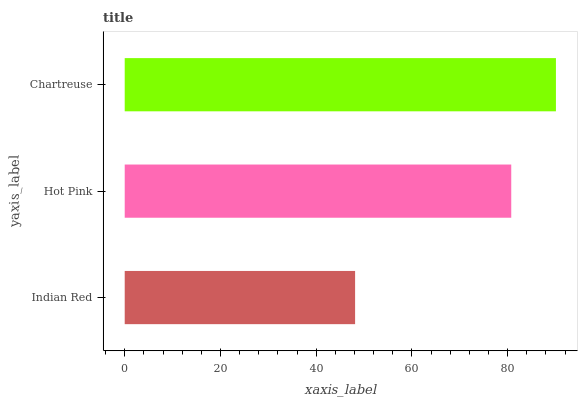Is Indian Red the minimum?
Answer yes or no. Yes. Is Chartreuse the maximum?
Answer yes or no. Yes. Is Hot Pink the minimum?
Answer yes or no. No. Is Hot Pink the maximum?
Answer yes or no. No. Is Hot Pink greater than Indian Red?
Answer yes or no. Yes. Is Indian Red less than Hot Pink?
Answer yes or no. Yes. Is Indian Red greater than Hot Pink?
Answer yes or no. No. Is Hot Pink less than Indian Red?
Answer yes or no. No. Is Hot Pink the high median?
Answer yes or no. Yes. Is Hot Pink the low median?
Answer yes or no. Yes. Is Indian Red the high median?
Answer yes or no. No. Is Chartreuse the low median?
Answer yes or no. No. 